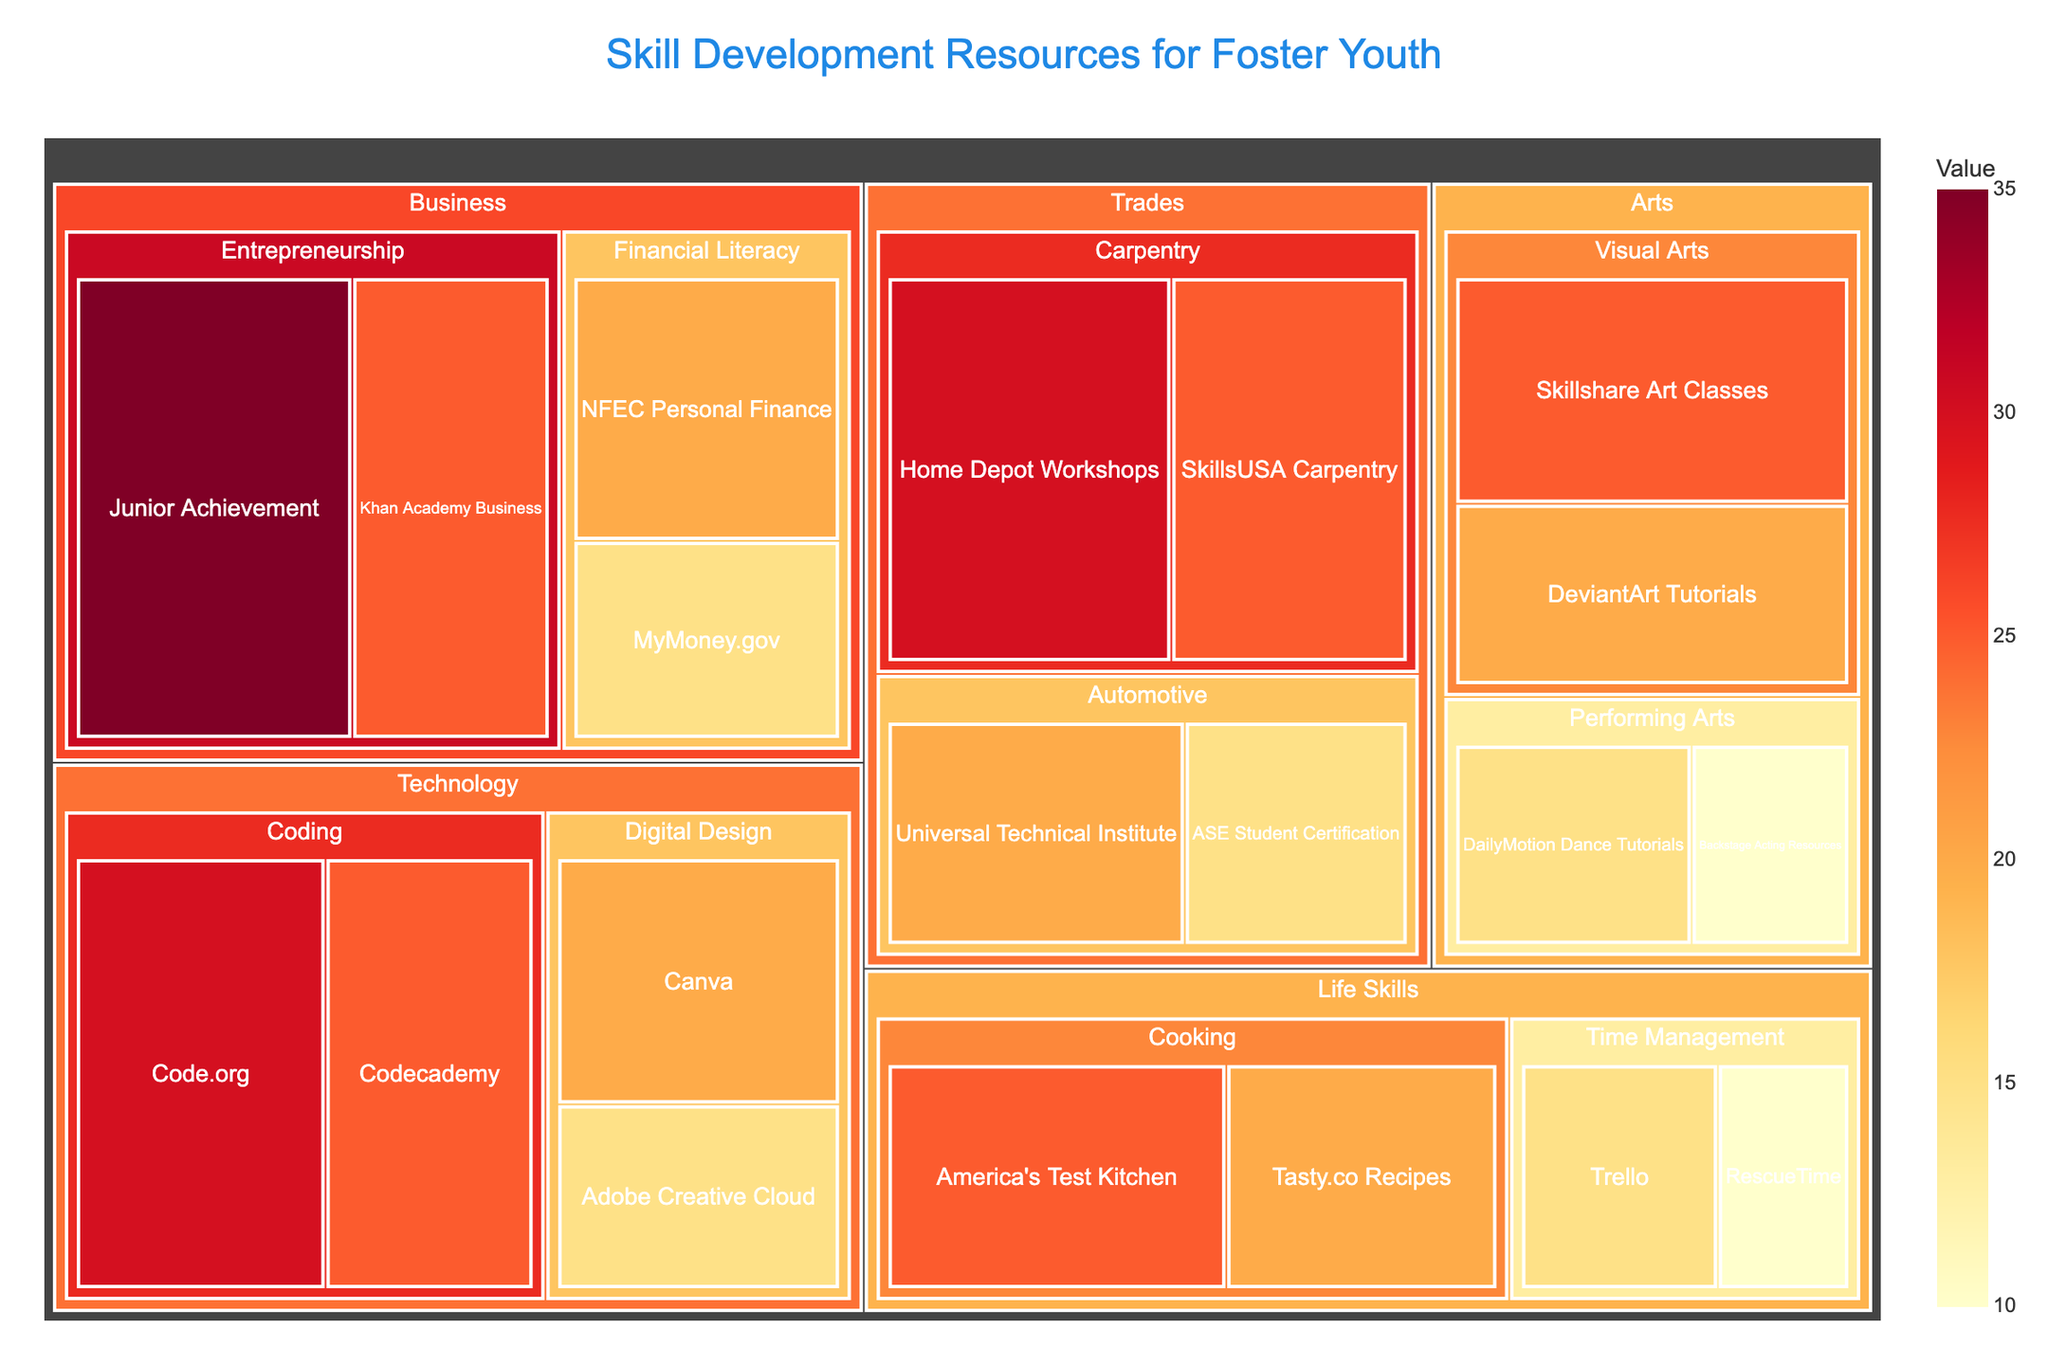What's the title of the Treemap? The title of the Treemap is displayed at the top center of the figure.
Answer: Skill Development Resources for Foster Youth Which resource in the Technology area has the highest value? In the Technology area, you see that Code.org within the Coding category has the largest portion represented by the area with a value of 30.
Answer: Code.org How many categories are there in the Life Skills area? The Life Skills area contains blocks for Cooking and Time Management categories. Counting these, we have 2 categories.
Answer: 2 What is the combined value of resources in the Business area? Adding up the values for Junior Achievement, Khan Academy Business, NFEC Personal Finance, and MyMoney.gov, we get 35 + 25 + 20 + 15, which totals 95.
Answer: 95 Which area has the smallest total value and what is that value? To find the smallest total value, sum the values for each area and compare. Adding them up: Technology (30+25+20+15 = 90), Business (95), Arts (25+20+15+10 = 70), Trades (30+25+20+15 = 90), Life Skills (25+20+15+10 = 70). Arts and Life Skills both have the smallest total of 70.
Answer: Arts and Life Skills, 70 In which category does Junior Achievement fall, and which area does this category belong to? Junior Achievement falls under the Entrepreneurship category, which belongs to the Business area.
Answer: Entrepreneurship, Business Compare the value of Skillshare Art Classes to the combined value of DeviantArt Tutorials and Backstage Acting Resources. Which is greater? Skillshare Art Classes has a value of 25. The combined value of DeviantArt Tutorials (20) and Backstage Acting Resources (10) is 30. Comparing these, 30 is greater than 25.
Answer: DeviantArt Tutorials and Backstage Acting Resources What's the average value of all resources in the Trades area? The values in the Trades area are 30 (Home Depot Workshops), 25 (SkillsUSA Carpentry), 20 (Universal Technical Institute), and 15 (ASE Student Certification). The total is 90, and there are 4 resources. So, the average is 90/4 = 22.5.
Answer: 22.5 Which category in the Life Skills area has the higher total value? In the Life Skills area, Cooking (America's Test Kitchen – 25 and Tasty.co Recipes – 20) totals 45, while Time Management (Trello – 15 and RescueTime – 10) totals 25. Comparing these, Cooking has the higher total value.
Answer: Cooking What's the difference in values between Universal Technical Institute and Kand Academy Business resources? Universal Technical Institute has a value of 20 and Khan Academy Business has a value of 25. The difference is 25 - 20 = 5.
Answer: 5 